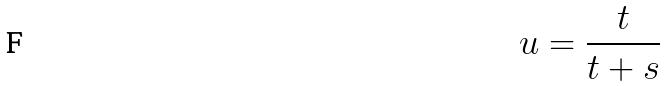<formula> <loc_0><loc_0><loc_500><loc_500>u = \frac { t } { t + s }</formula> 